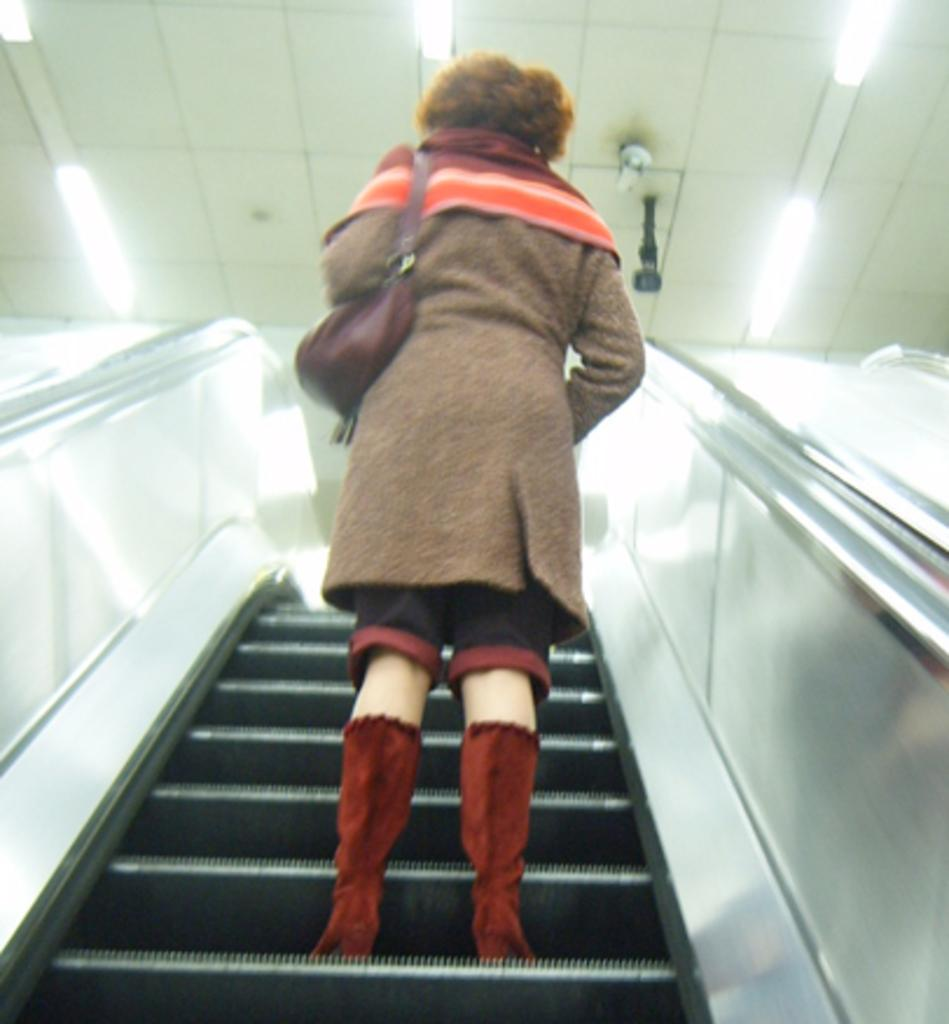Who or what is in the image? There is a person in the image. What is the person doing in the image? The person is standing on an escalator. What is the person holding in the image? The person is holding a bag. What can be seen above the person in the image? There is a roof visible in the image, with lights and objects attached to it. Can you see a cat jumping out of the person's pocket in the image? No, there is no cat present in the image, nor is there a pocket visible on the person. 